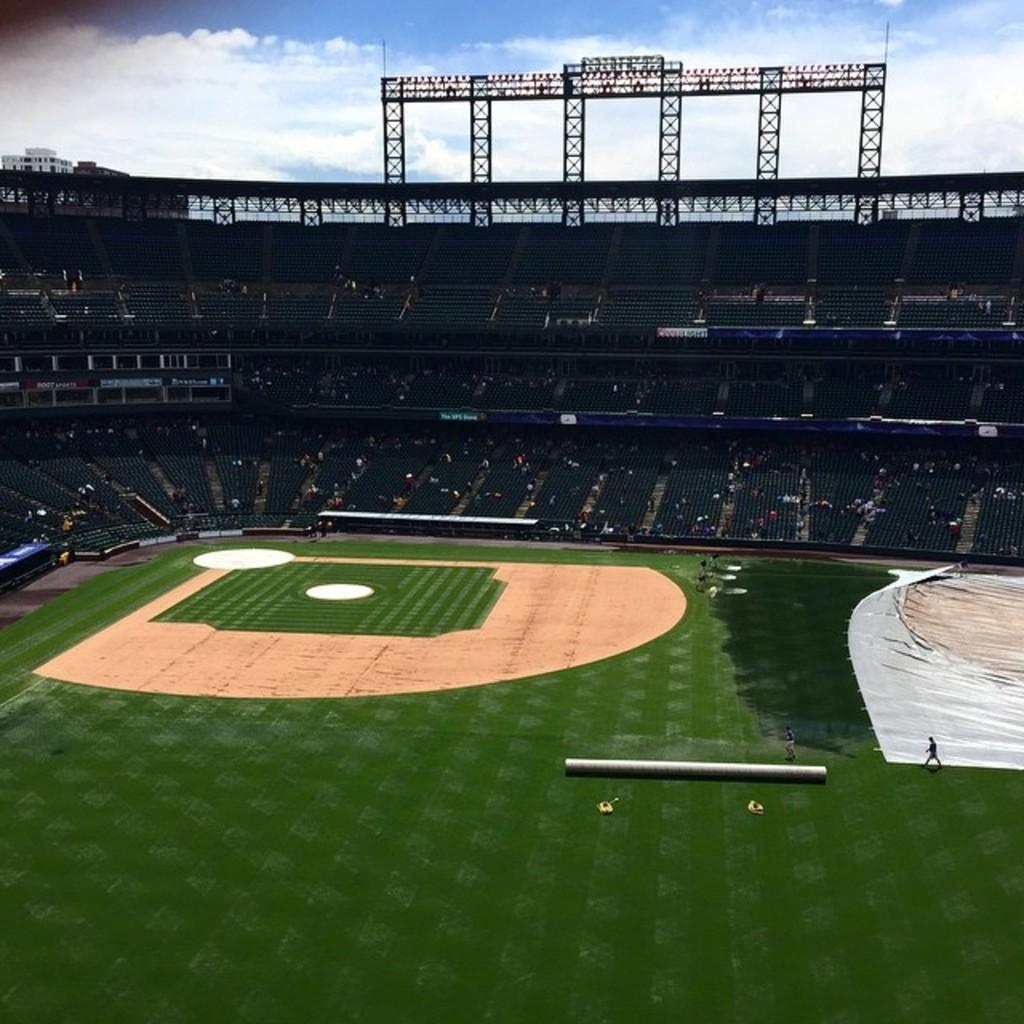Please provide a concise description of this image. This is a stadium. At the bottom of the image I can see the ground. On the right side, I can see a white color sheet on the ground. In the background, I can see the stairs and chairs in the dark. At the top I can see few poles. At the top of the image I can see the sky and clouds. 